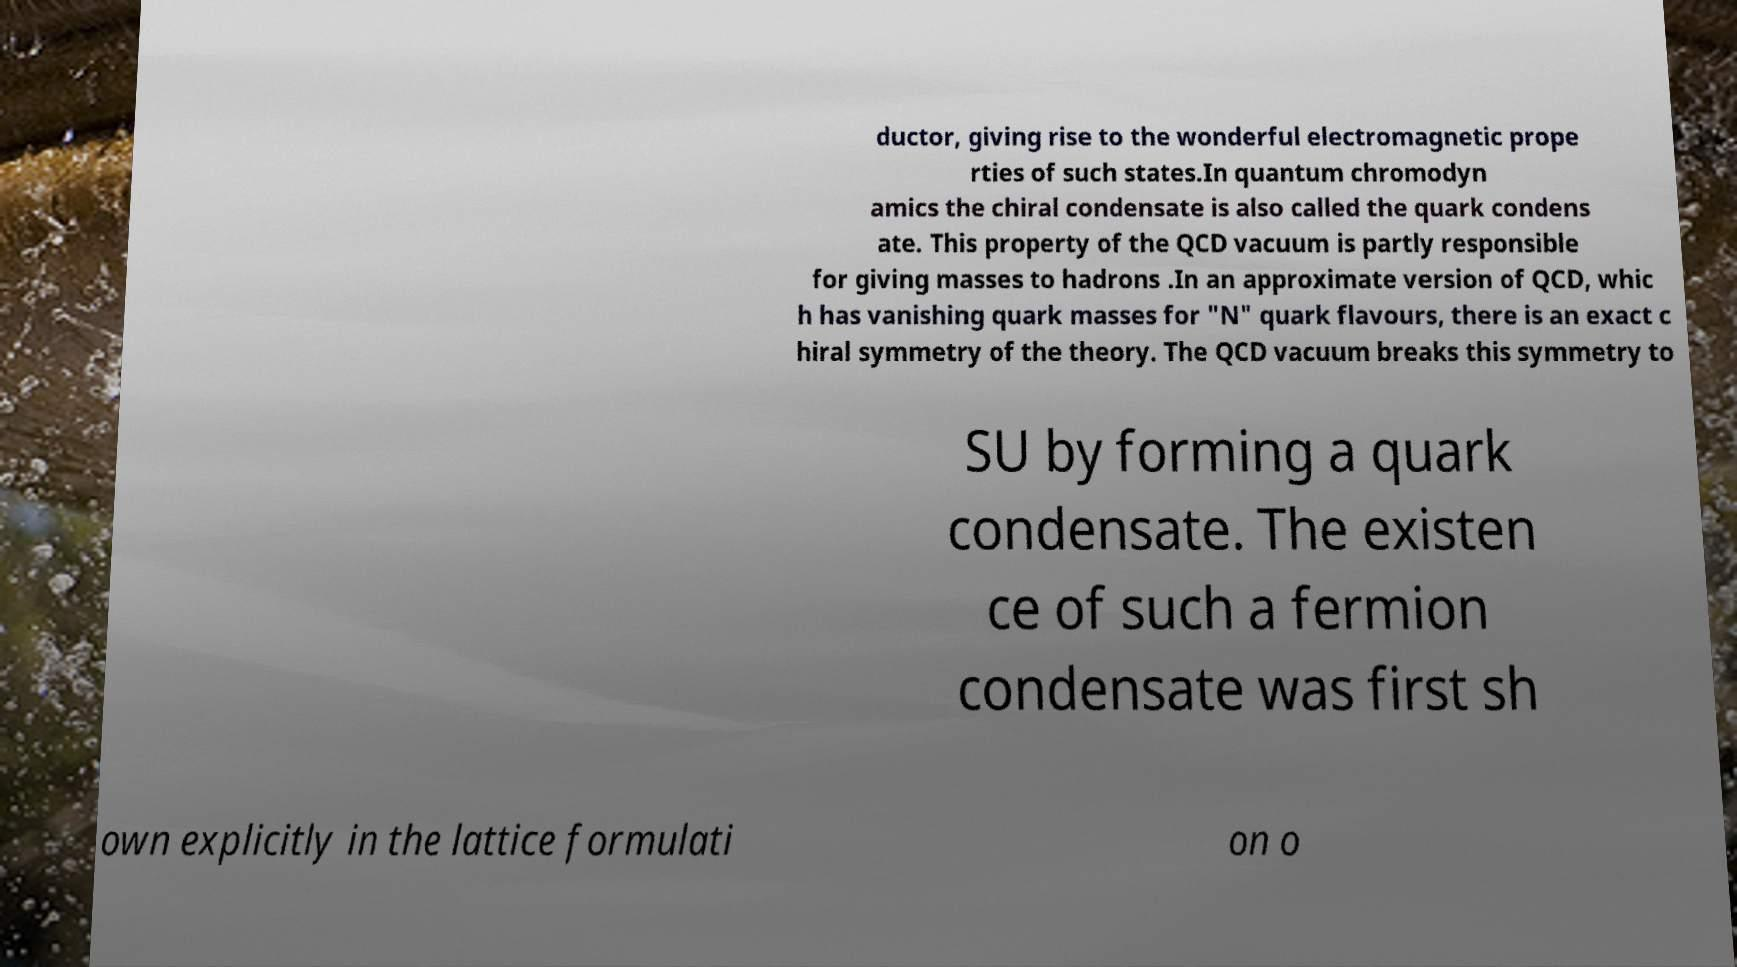For documentation purposes, I need the text within this image transcribed. Could you provide that? ductor, giving rise to the wonderful electromagnetic prope rties of such states.In quantum chromodyn amics the chiral condensate is also called the quark condens ate. This property of the QCD vacuum is partly responsible for giving masses to hadrons .In an approximate version of QCD, whic h has vanishing quark masses for "N" quark flavours, there is an exact c hiral symmetry of the theory. The QCD vacuum breaks this symmetry to SU by forming a quark condensate. The existen ce of such a fermion condensate was first sh own explicitly in the lattice formulati on o 